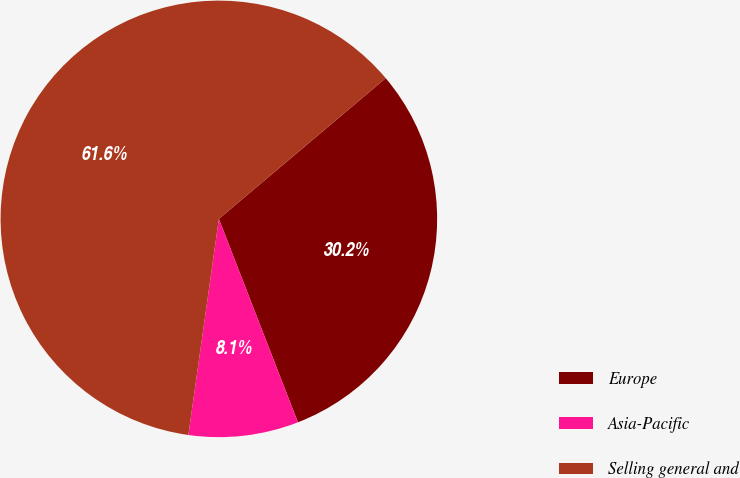Convert chart. <chart><loc_0><loc_0><loc_500><loc_500><pie_chart><fcel>Europe<fcel>Asia-Pacific<fcel>Selling general and<nl><fcel>30.25%<fcel>8.13%<fcel>61.62%<nl></chart> 